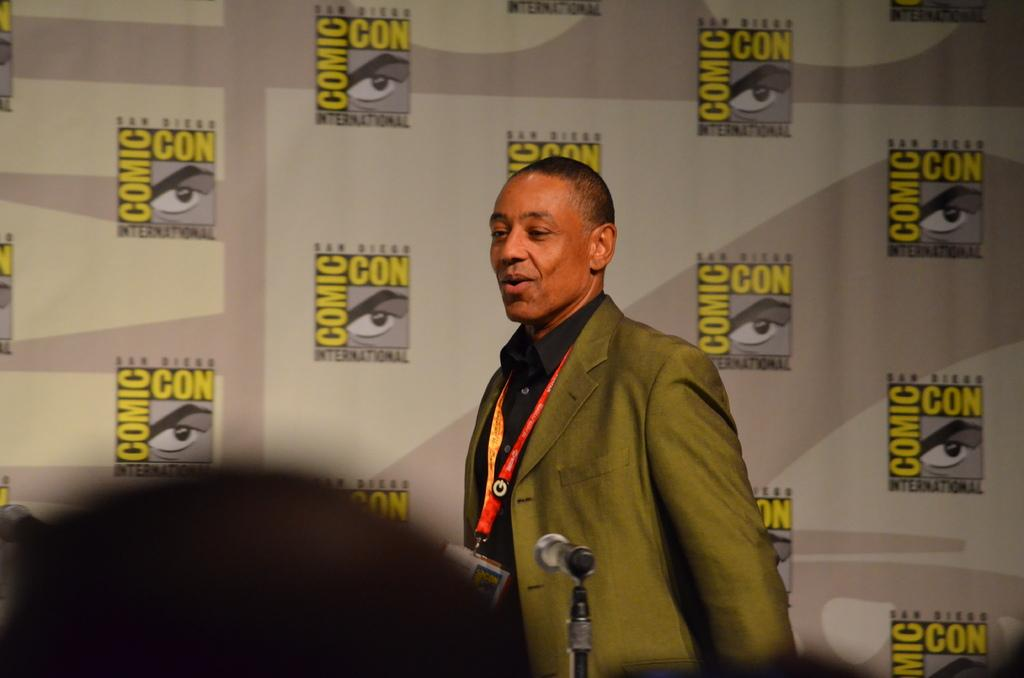What is the main subject of the image? There is a man standing in the image. What object is present near the man? There is a microphone with a microphone stand in the image. What can be seen in the background of the image? There is a board visible in the background of the image. What type of match is being played in the image? There is no match being played in the image; it features a man standing near a microphone and a board visible in the background. 